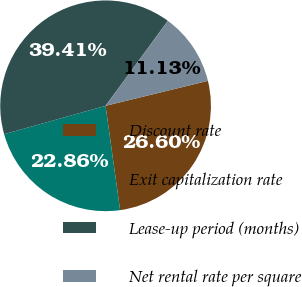Convert chart. <chart><loc_0><loc_0><loc_500><loc_500><pie_chart><fcel>Discount rate<fcel>Exit capitalization rate<fcel>Lease-up period (months)<fcel>Net rental rate per square<nl><fcel>26.6%<fcel>22.86%<fcel>39.41%<fcel>11.13%<nl></chart> 